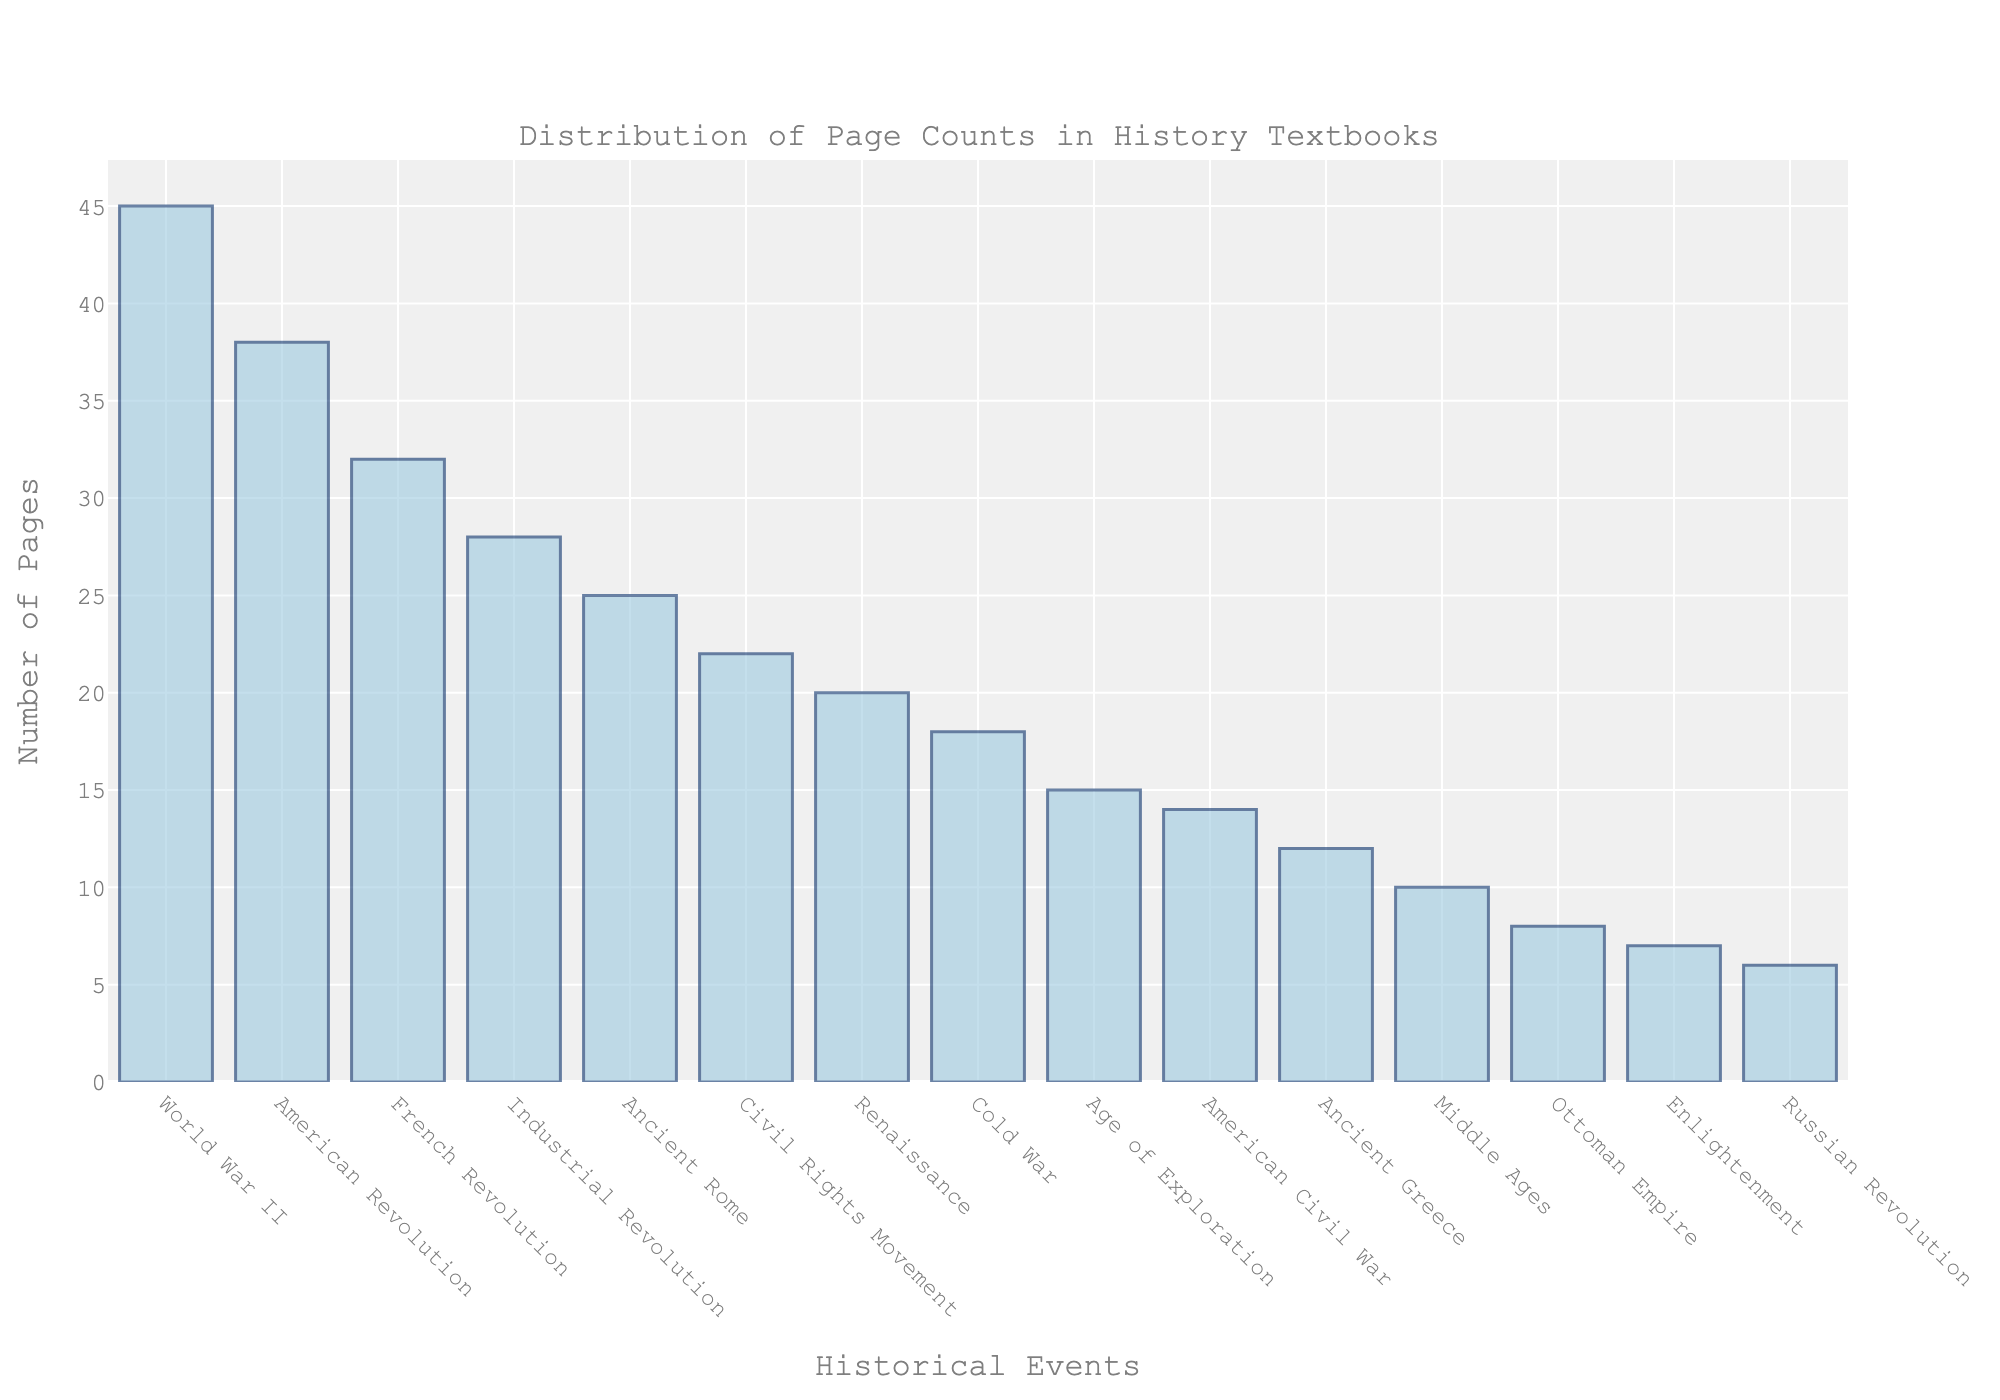Which historical event has the highest page count? The figure shows that the bar corresponding to World War II is the tallest. Thus, this event has the highest page count.
Answer: World War II Which historical event has the lowest page count? In the chart, the bar representing the Russian Revolution is the shortest. This indicates that this event has the lowest page count.
Answer: Russian Revolution How many total pages are dedicated to the American Revolution and the French Revolution combined? According to the chart, the American Revolution has 38 pages and the French Revolution has 32 pages. Adding these gives 38 + 32 = 70.
Answer: 70 Which event has more pages dedicated to it: the Renaissance or the Age of Exploration? By comparing the heights of the bars, the Renaissance has a taller bar compared to the Age of Exploration. This indicates more pages are dedicated to the Renaissance.
Answer: Renaissance What is the difference in the number of pages between the World War II and the Industrial Revolution? The figure shows World War II has 45 pages and the Industrial Revolution has 28 pages. The difference is 45 - 28 = 17.
Answer: 17 Which historical events have an equal number of pages dedicated to them? By observing the heights of the bars, no two bars are of equal height. Thus, no events have an equal number of pages dedicated to them.
Answer: None What is the sum of the pages dedicated to Ancient Rome, Ancient Greece, and the Middle Ages? From the chart, Ancient Rome has 25 pages, Ancient Greece has 12 pages, and the Middle Ages has 10 pages. Adding these values gives 25 + 12 + 10 = 47.
Answer: 47 Is the page count for the Cold War more or less than the page count for the Civil Rights Movement? The bar representing the Cold War is shorter than the one for the Civil Rights Movement. Thus, the Cold War has fewer pages.
Answer: Less What is the median page count dedicated to the events listed? To find the median, list all the page counts in ascending order: 6, 7, 8, 10, 12, 14, 15, 18, 20, 22, 25, 28, 32, 38, 45. The median is the middle value in this ordered list, which is 18.
Answer: 18 How many more pages are dedicated to the American Civil War than to the Ottoman Empire? The page count for the American Civil War is 14 and for the Ottoman Empire is 8. The difference is 14 - 8 = 6.
Answer: 6 